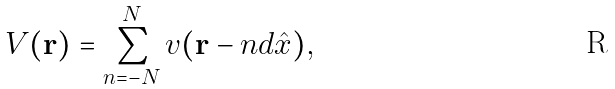Convert formula to latex. <formula><loc_0><loc_0><loc_500><loc_500>V ( { \mathbf r } ) = \sum _ { n = - N } ^ { N } v ( { \mathbf r } - n d \hat { x } ) ,</formula> 